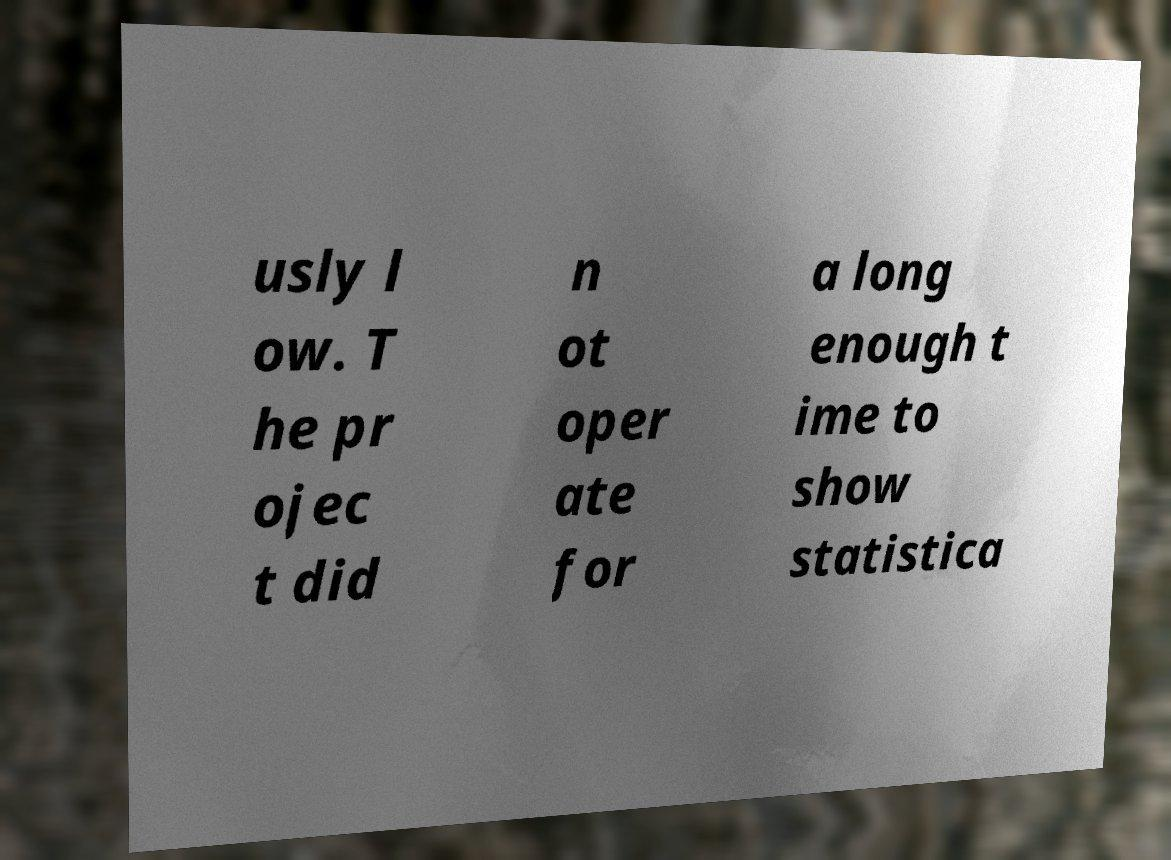Can you accurately transcribe the text from the provided image for me? usly l ow. T he pr ojec t did n ot oper ate for a long enough t ime to show statistica 